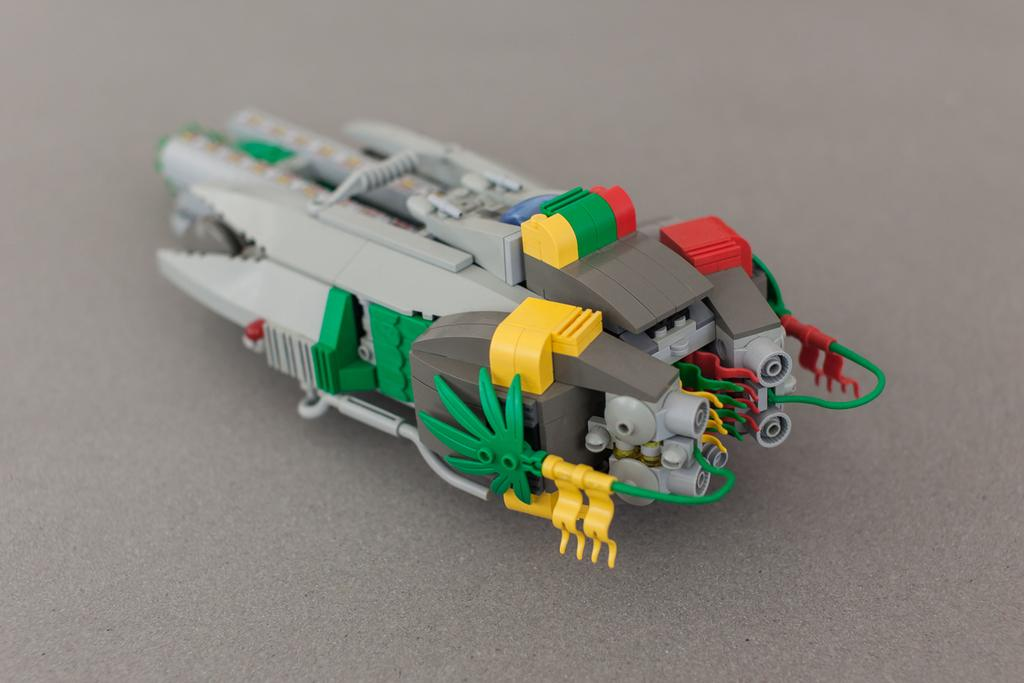What is the main object in the image? There is a toy in the image. What is the toy placed on? The toy is on a gray surface. How many marbles are rolling on the top of the toy in the image? There are no marbles present in the image, and the toy does not have a top. 